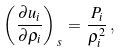<formula> <loc_0><loc_0><loc_500><loc_500>\left ( \frac { \partial u _ { i } } { \partial \rho _ { i } } \right ) _ { \, s } \, = \, \frac { P _ { i } } { \rho _ { i } ^ { 2 } } \, ,</formula> 